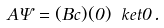Convert formula to latex. <formula><loc_0><loc_0><loc_500><loc_500>A \Psi = ( B c ) ( 0 ) \ k e t { 0 } \, .</formula> 